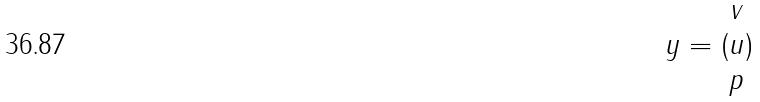<formula> <loc_0><loc_0><loc_500><loc_500>y = ( \begin{matrix} v \\ u \\ p \end{matrix} )</formula> 